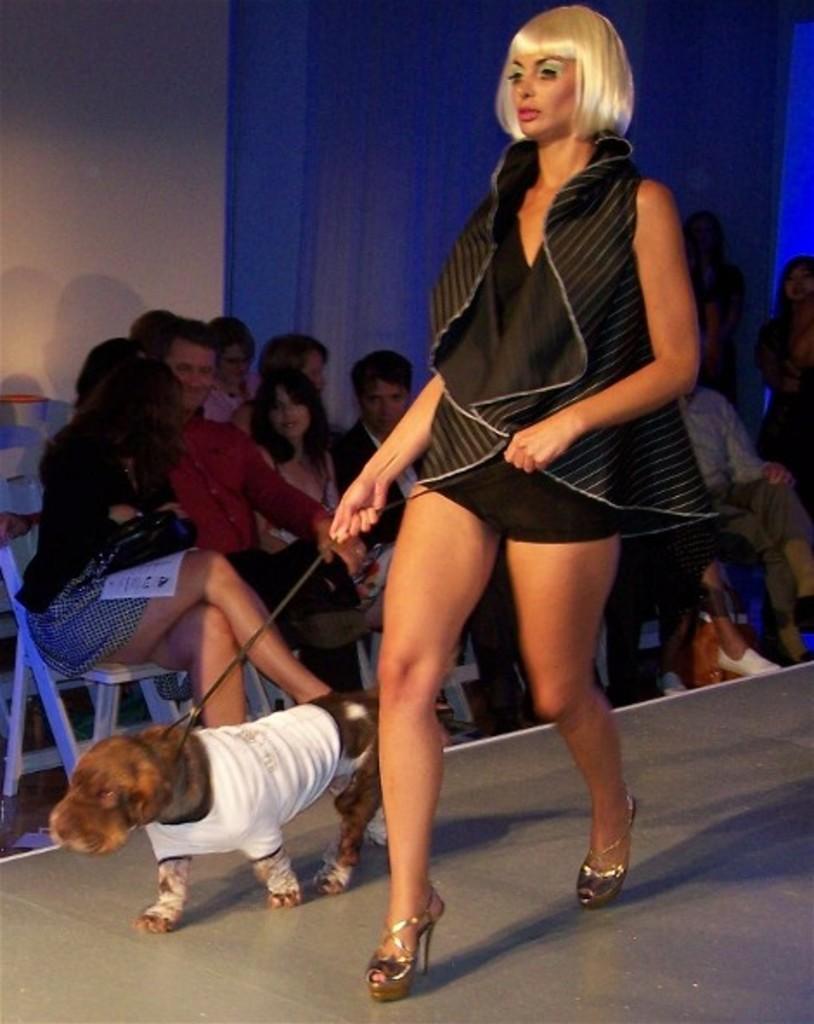Please provide a concise description of this image. In this picture we can see woman holding rope in her hand and beside to her dog wore clothes and they are on ramp walk and beside to the path people sitting on chairs and looking at each other and in background we can see wall, curtains. 